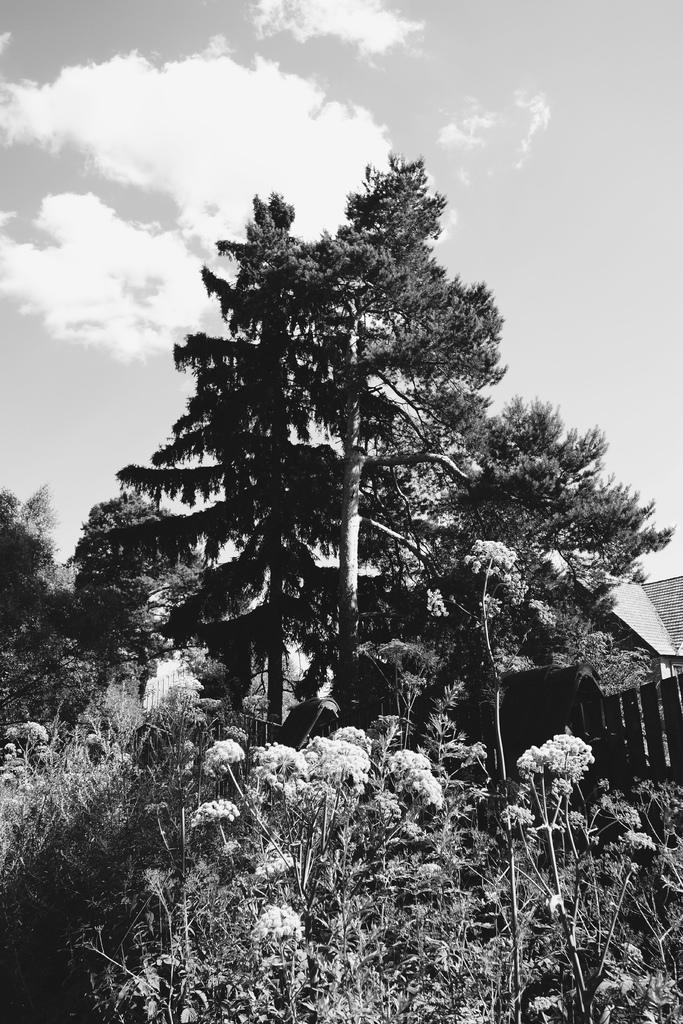What is the color scheme of the image? The image is black and white. What type of vegetation can be seen at the bottom of the image? There are plants with flowers at the bottom of the image. What can be seen in the background of the image? There are trees, a house, and clouds in the sky in the background of the image. How many chickens are sitting on the table in the image? There are no chickens or tables present in the image. 